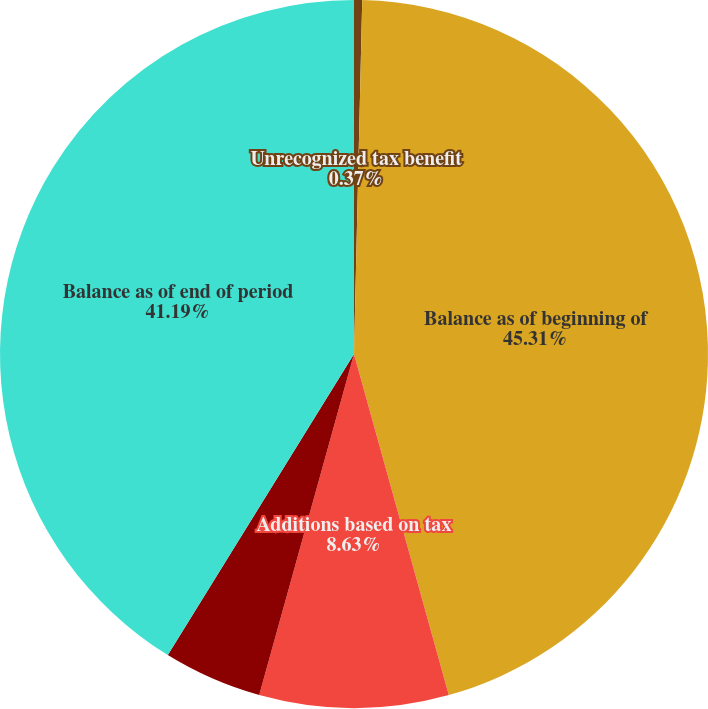Convert chart. <chart><loc_0><loc_0><loc_500><loc_500><pie_chart><fcel>Unrecognized tax benefit<fcel>Balance as of beginning of<fcel>Additions based on tax<fcel>Reductions based on tax<fcel>Balance as of end of period<nl><fcel>0.37%<fcel>45.32%<fcel>8.63%<fcel>4.5%<fcel>41.19%<nl></chart> 